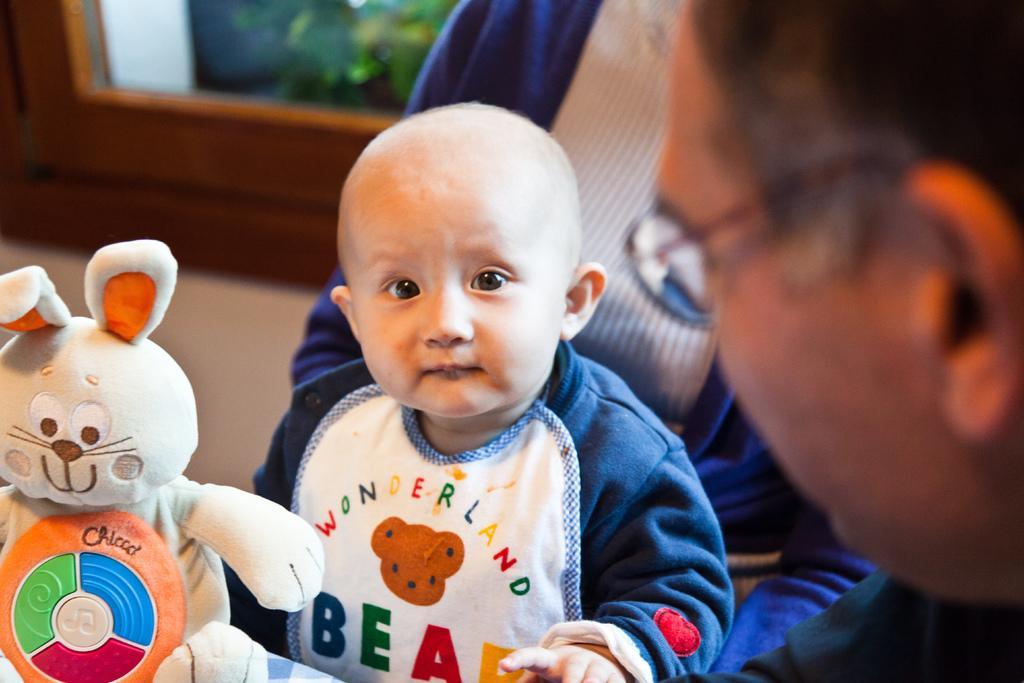Can you describe this image briefly? In this image I can see a child wearing blue and white colored dress and a toy which is cream, orange, green, blue and red in color in front of him. I can see a person's head wearing glasses. In the background I can see the wall and the window through which I can see few trees. 